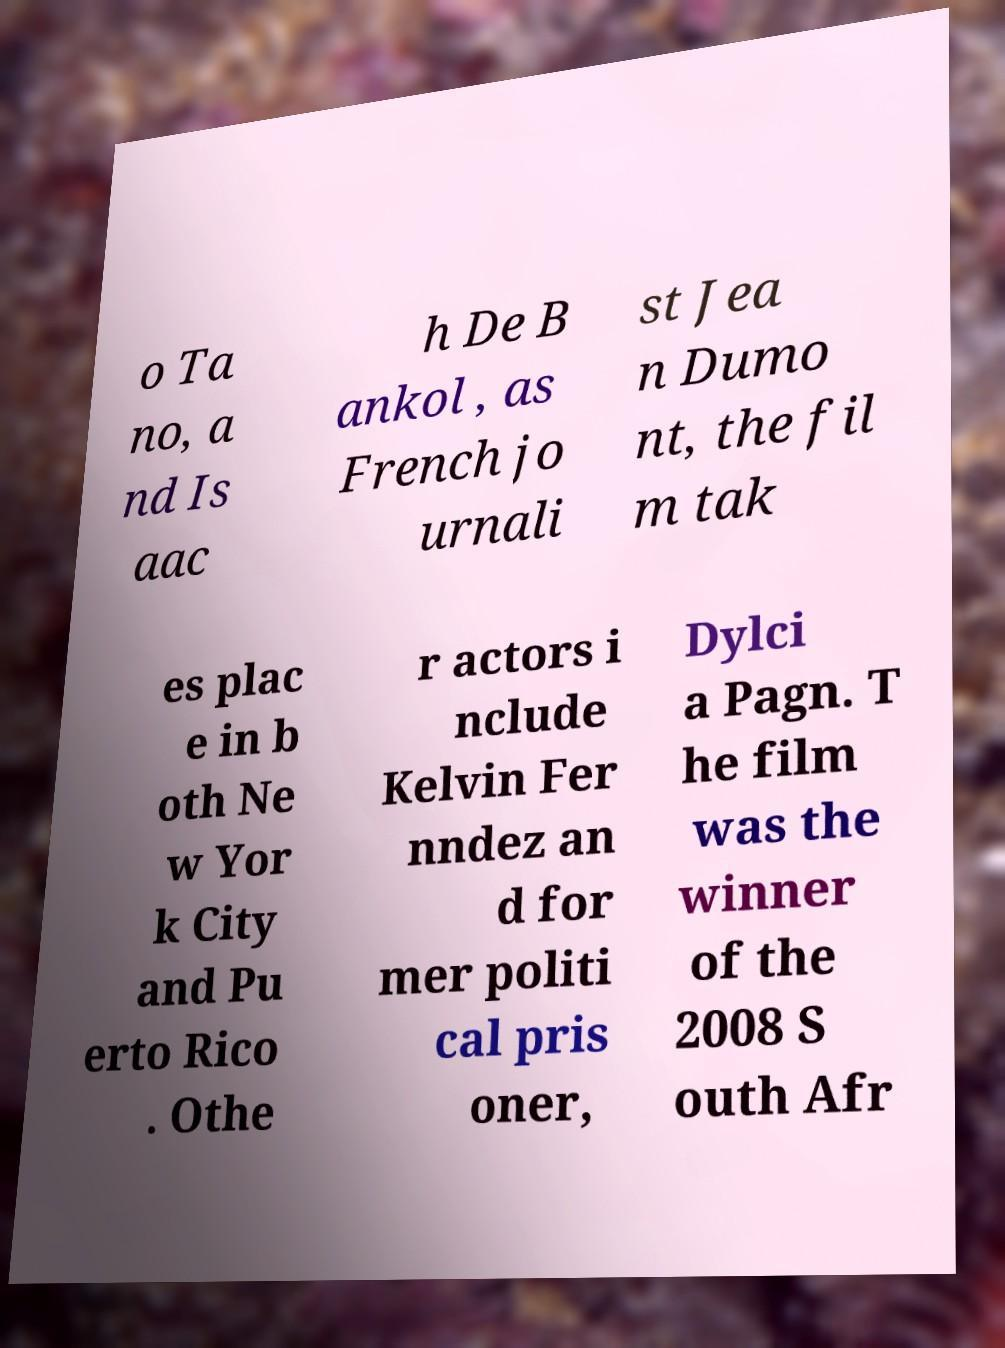Can you accurately transcribe the text from the provided image for me? o Ta no, a nd Is aac h De B ankol , as French jo urnali st Jea n Dumo nt, the fil m tak es plac e in b oth Ne w Yor k City and Pu erto Rico . Othe r actors i nclude Kelvin Fer nndez an d for mer politi cal pris oner, Dylci a Pagn. T he film was the winner of the 2008 S outh Afr 